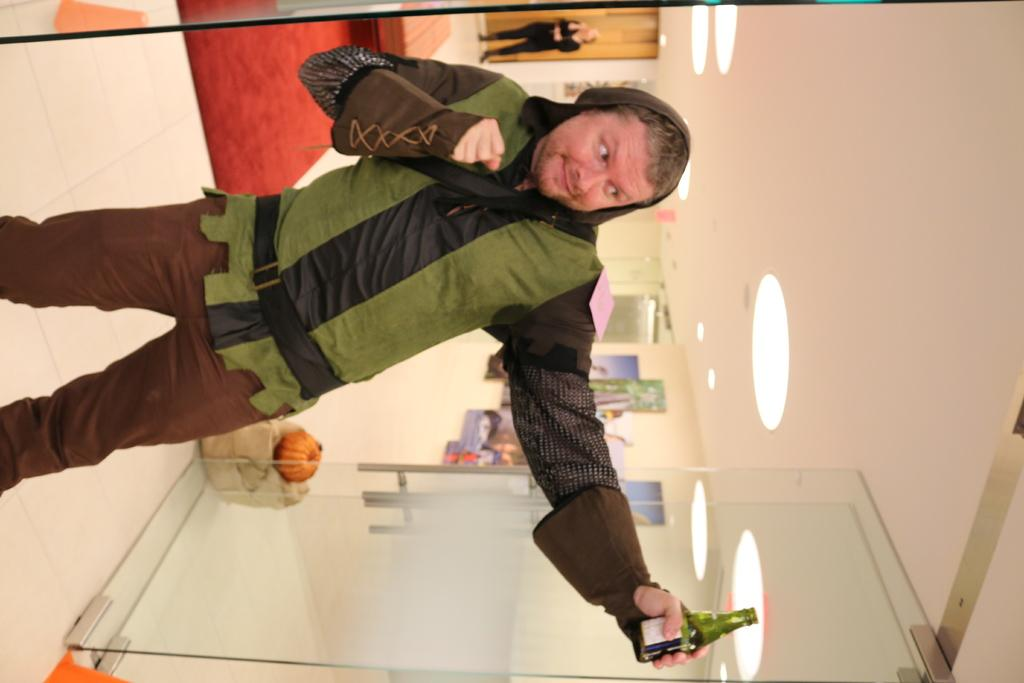What is the person in the image doing? The person is standing in the image and holding a bottle. What is the surface beneath the person's feet? There is a floor in the image. What type of barrier is present in the image? There is a glass door in the image. What can be seen at the top of the image? There are lights visible at the top of the image. Can you describe the other person in the image? There is another person standing far away in the image. What type of balloon is floating near the ceiling in the image? There is no balloon present in the image. What design is featured on the floor in the image? The facts provided do not mention any specific design on the floor. 